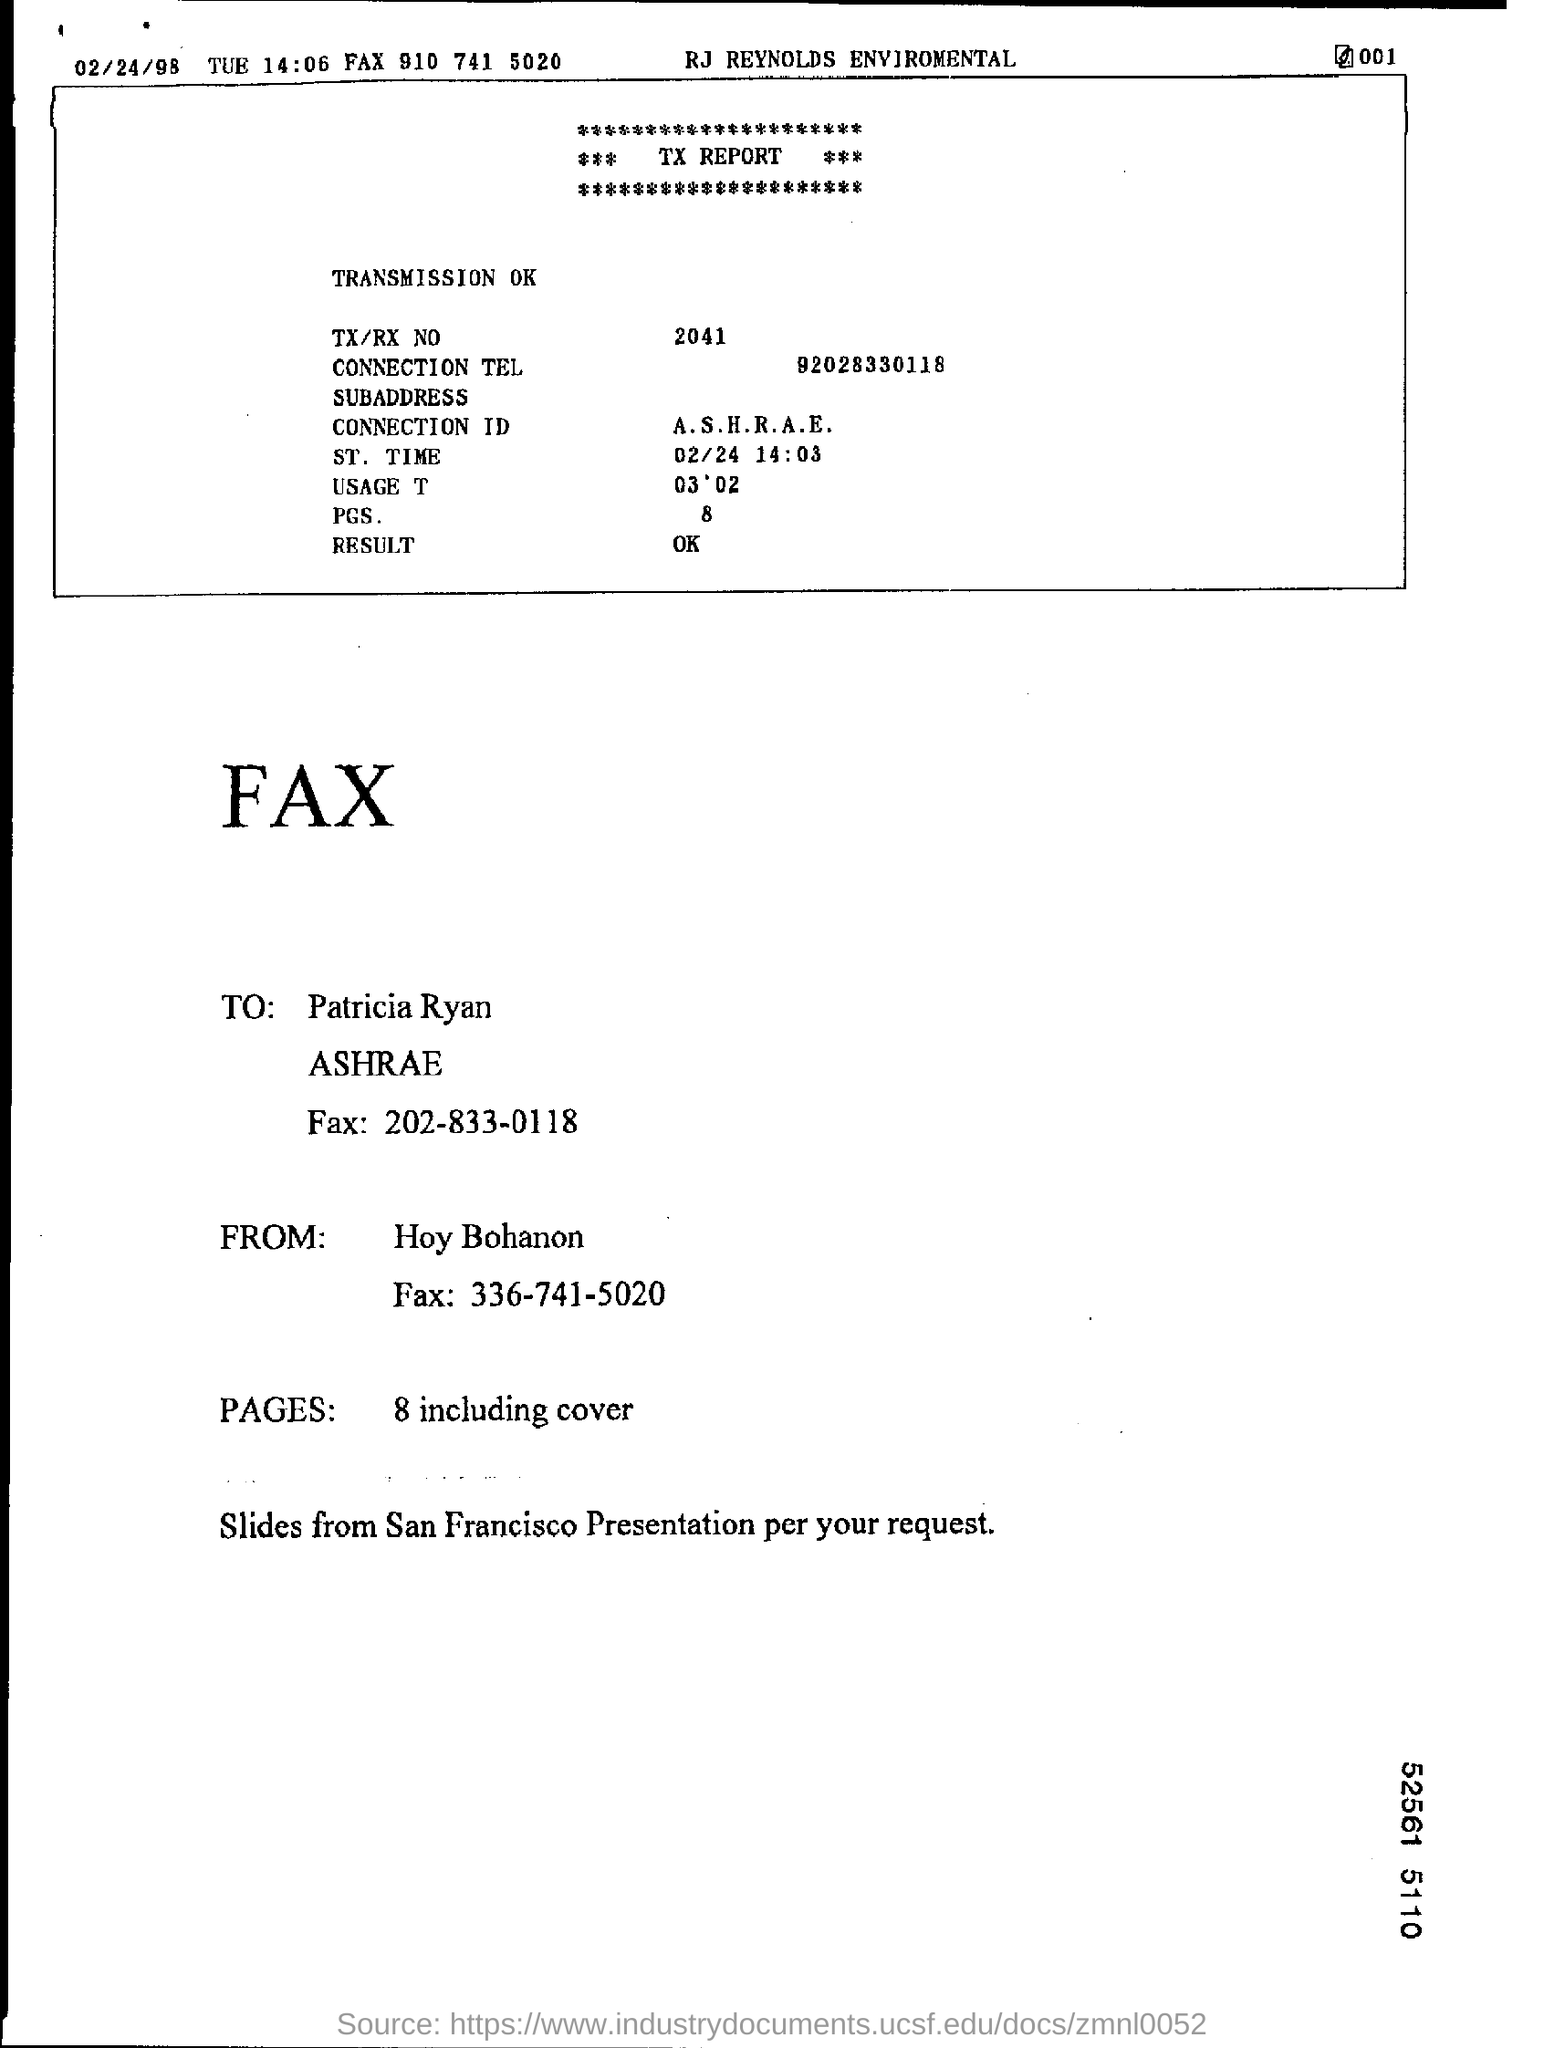What is the ST. Time?
 02/24 14:03 